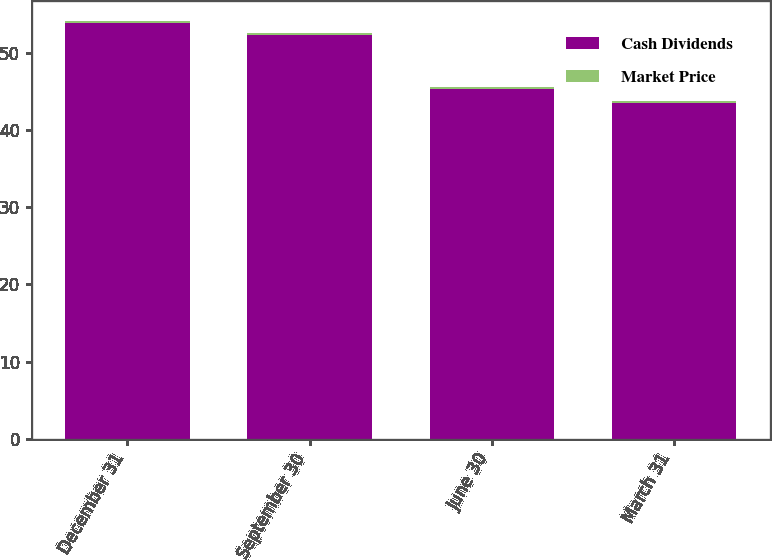Convert chart to OTSL. <chart><loc_0><loc_0><loc_500><loc_500><stacked_bar_chart><ecel><fcel>December 31<fcel>September 30<fcel>June 30<fcel>March 31<nl><fcel>Cash Dividends<fcel>53.91<fcel>52.36<fcel>45.4<fcel>43.6<nl><fcel>Market Price<fcel>0.24<fcel>0.24<fcel>0.24<fcel>0.24<nl></chart> 